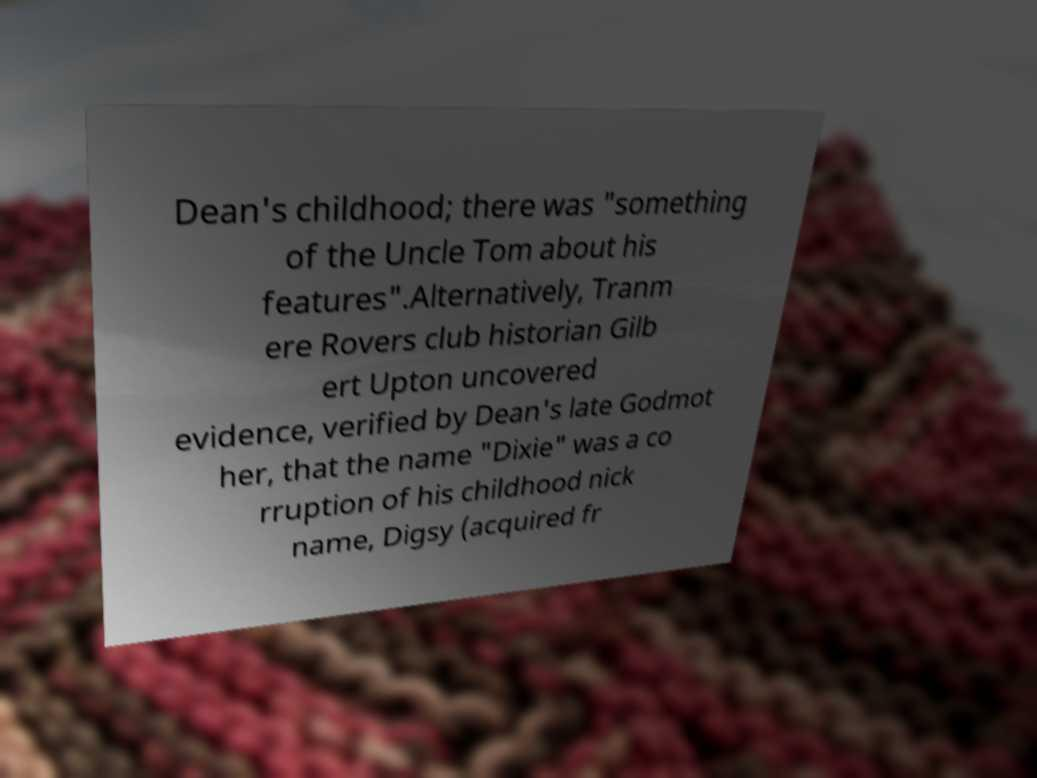For documentation purposes, I need the text within this image transcribed. Could you provide that? Dean's childhood; there was "something of the Uncle Tom about his features".Alternatively, Tranm ere Rovers club historian Gilb ert Upton uncovered evidence, verified by Dean's late Godmot her, that the name "Dixie" was a co rruption of his childhood nick name, Digsy (acquired fr 